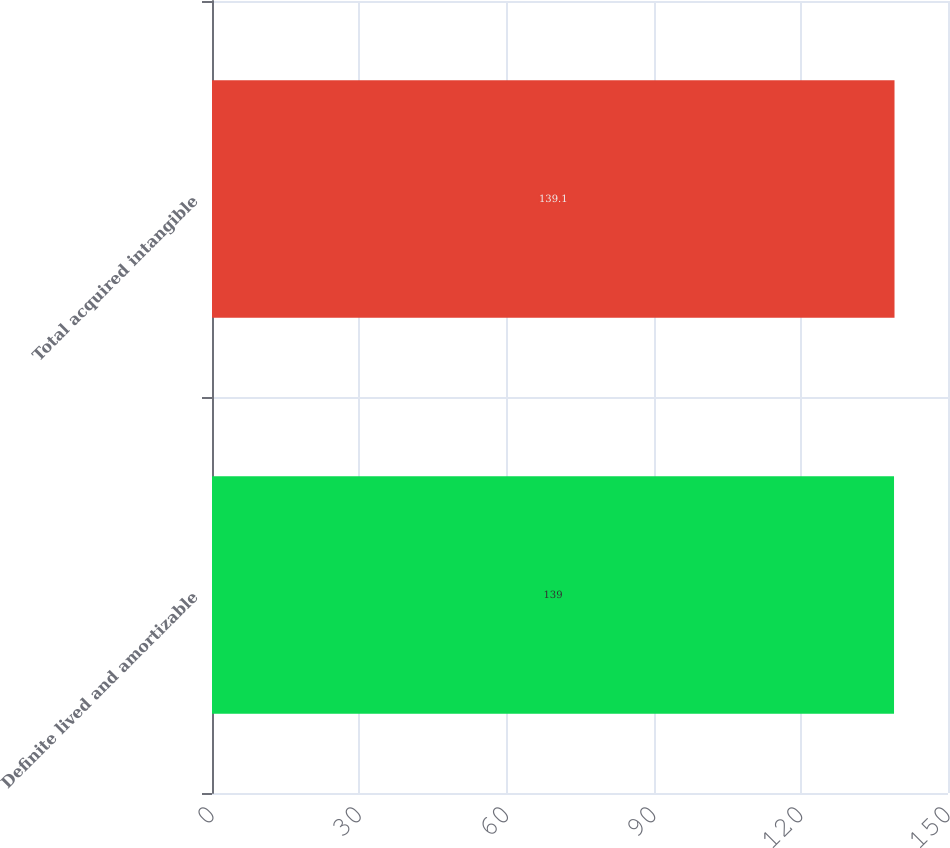Convert chart to OTSL. <chart><loc_0><loc_0><loc_500><loc_500><bar_chart><fcel>Definite lived and amortizable<fcel>Total acquired intangible<nl><fcel>139<fcel>139.1<nl></chart> 